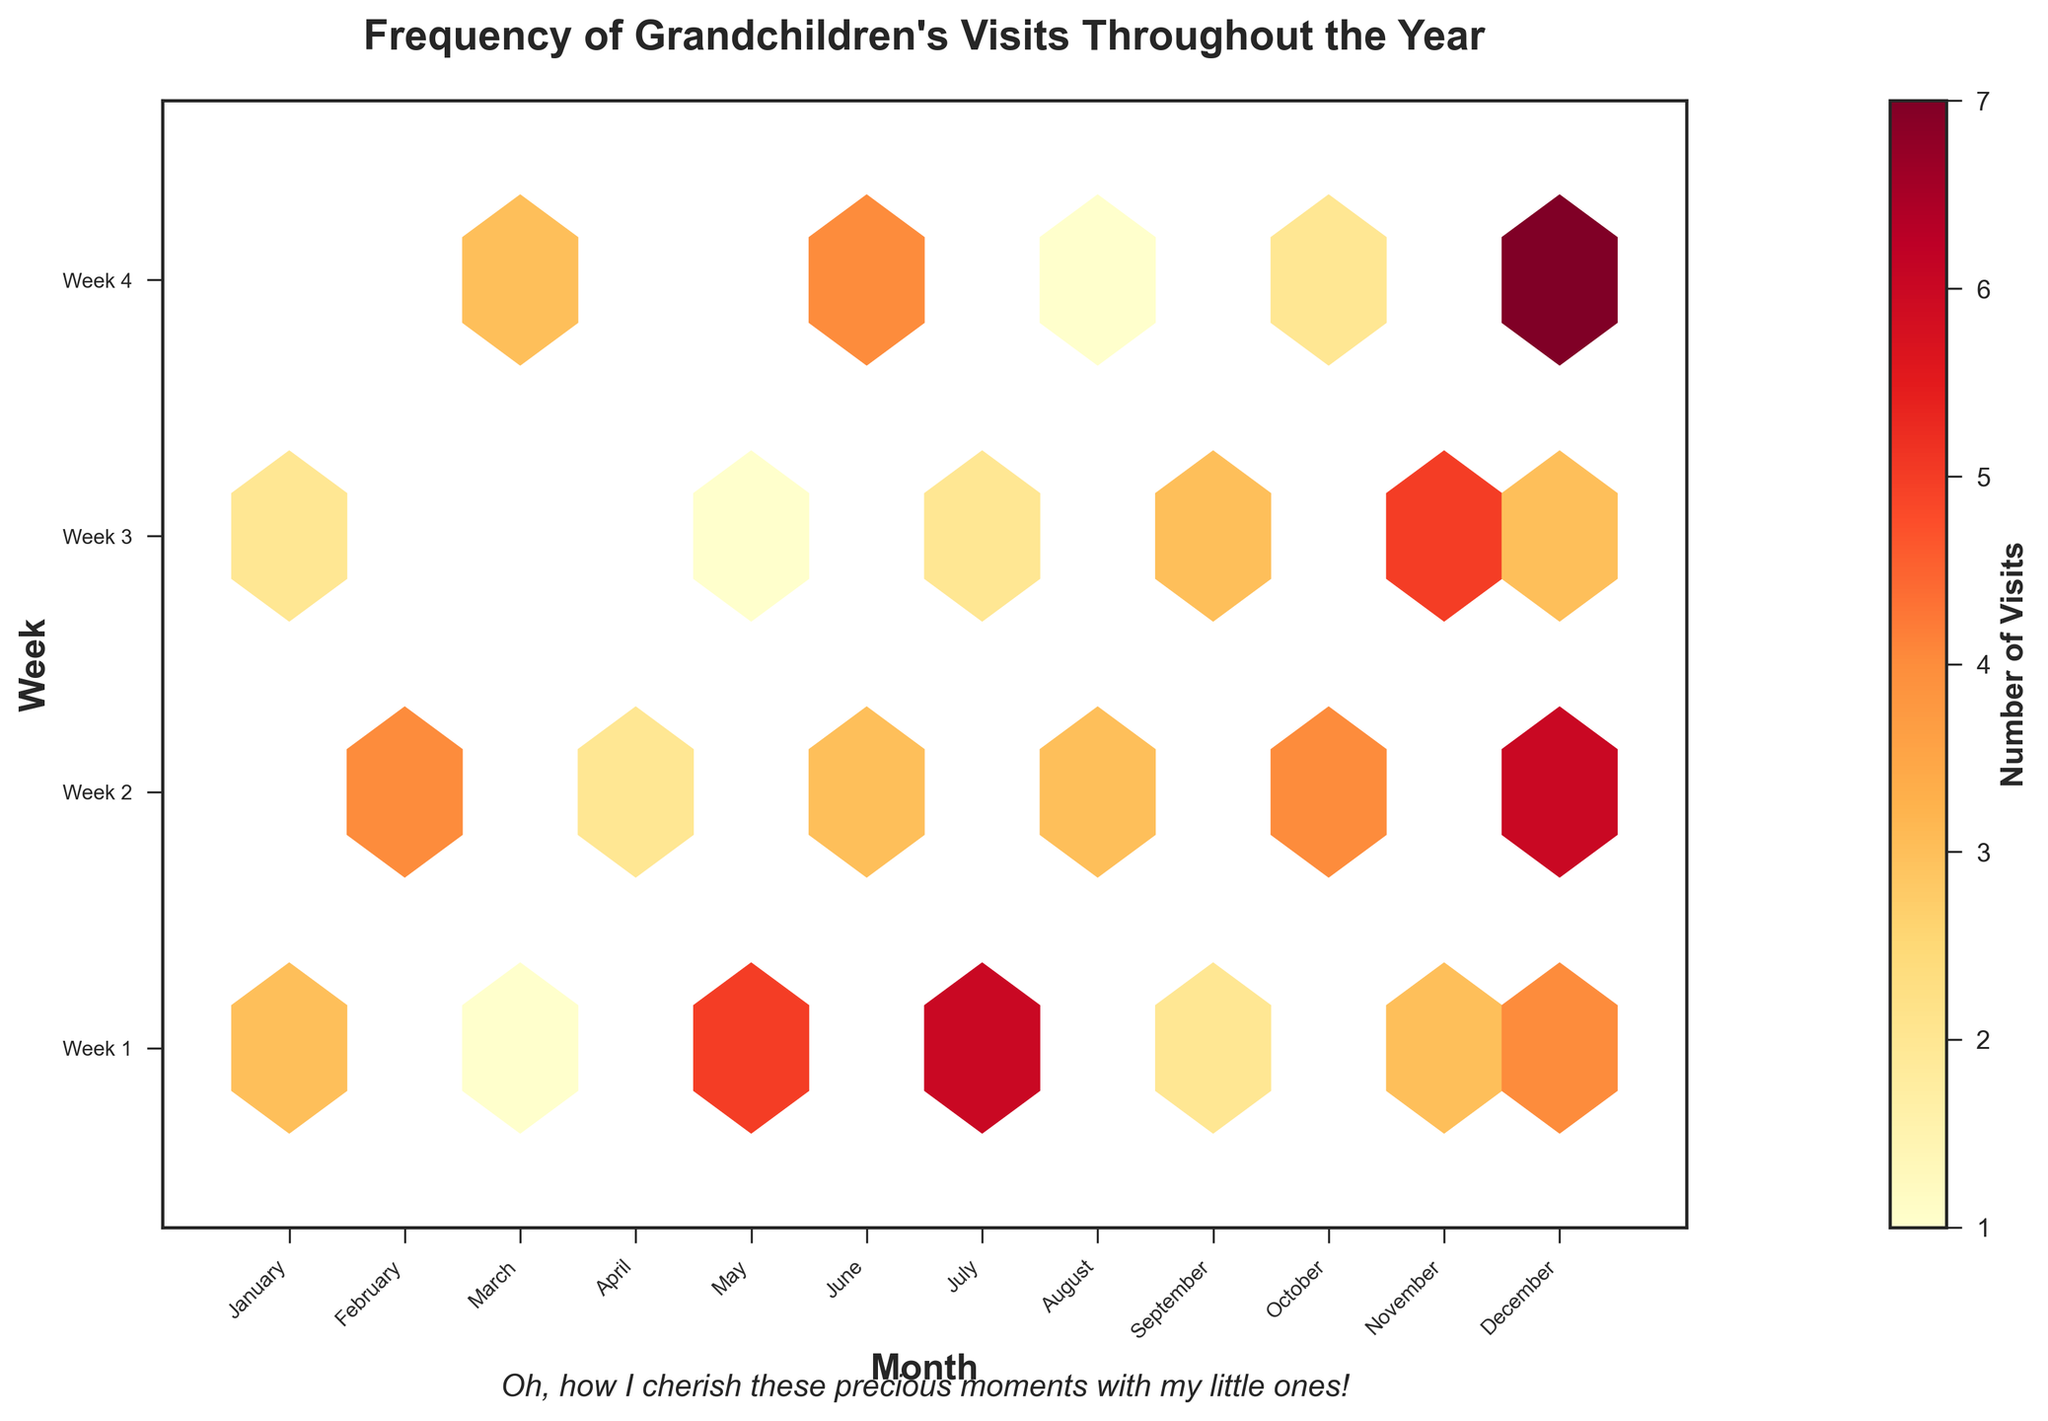What is the title of the plot? The title is usually at the top of the plot in a larger font. Here, it reads "Frequency of Grandchildren's Visits Throughout the Year."
Answer: Frequency of Grandchildren's Visits Throughout the Year Which month had the highest number of visits in any given week? Look at the color intensity in the hexbin plot. December has the darkest hexagon corresponding to Week 4, indicating the highest number of visits.
Answer: December What is the range of weeks shown in the plot? The y-axis displays the range of weeks. It is labeled from Week 1 to Week 4.
Answer: Week 1 to Week 4 Which months did not have any visits in Week 2? Check for lighter or missing hexagons in Week 2 across the months. March and November show no hexagon indication for Week 2.
Answer: March and November Which month seems to have the most evenly distributed visits across all weeks? Assess the color distribution in hexagons for each month. December shows hexagons with more even coloring across all four weeks, meaning visits are more evenly distributed.
Answer: December How many visits were recorded in July, Week 1? Find the hexagon corresponding to July and Week 1 and check the color bar's label. July, Week 1 shows a dark hexagon, indicating it had 6 visits.
Answer: 6 In which month does any week other than Week 4 have the highest number of visits? Compare hexagons in weeks other than Week 4 for all months. July, Week 1 has a significant number of visits, the highest noted for a non-Week 4 observation.
Answer: July Which weeks have no visits in May? Check for any lighter or missing hexagons in May. May, Week 2 has no corresponding hexagon, indicating no visits.
Answer: Week 2 What is the color of the hexagon representing December, Week 4, and what does it indicate? Locate the June/Week 4 hexagon and observe its color, which should correspond to the highest color on the colorbar, indicating it represents 7 visits.
Answer: Darkest Yellow, 7 visits Comparing May and November, which month had a higher number of visits overall, and how do you derive this? Analyze the hexagon colors for both months. May's hexagons are lighter indicating fewer visits (1, 5). November’s are darker indicating more visits (3, 5). November had more total visits.
Answer: November 